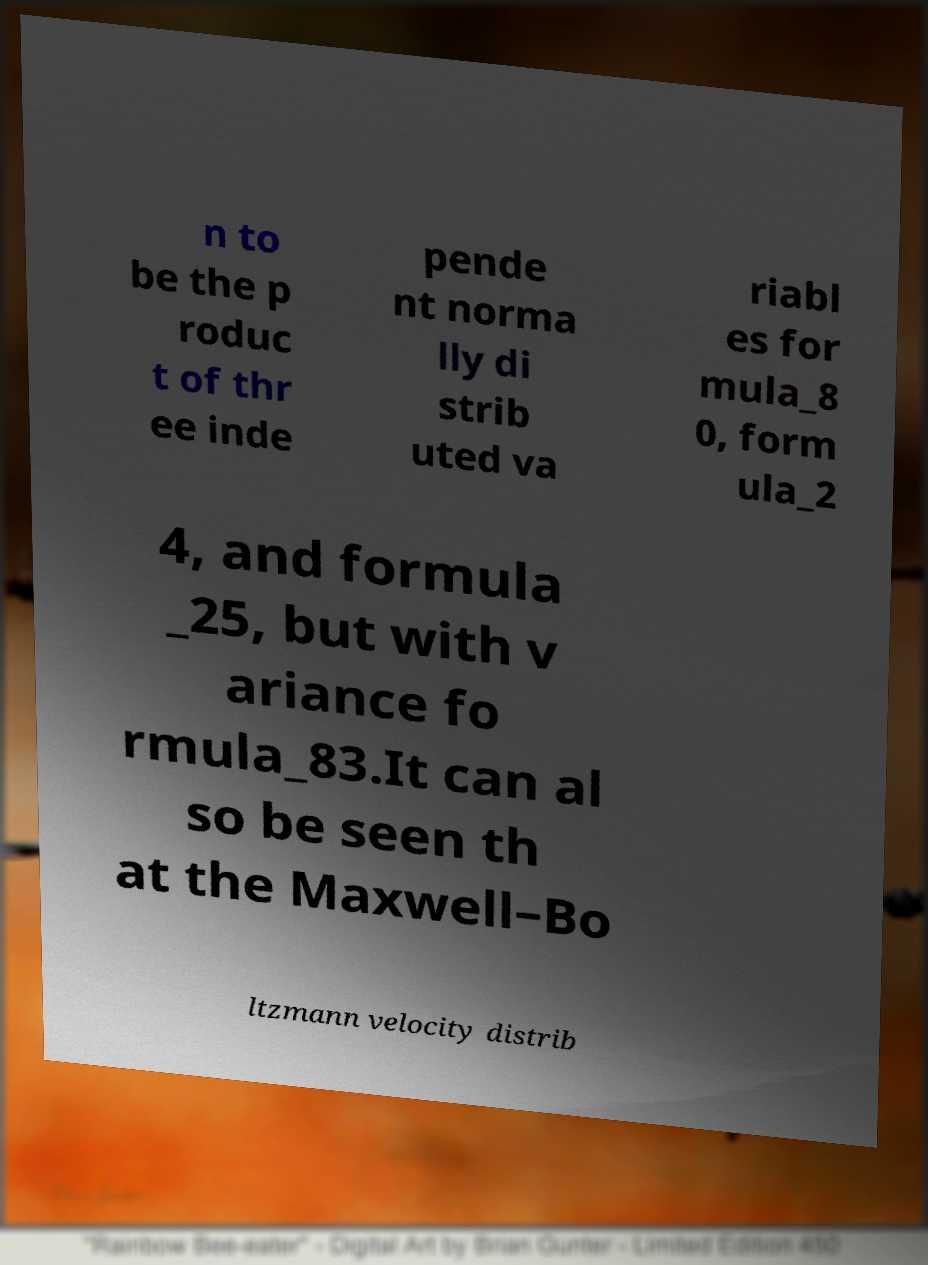Can you accurately transcribe the text from the provided image for me? n to be the p roduc t of thr ee inde pende nt norma lly di strib uted va riabl es for mula_8 0, form ula_2 4, and formula _25, but with v ariance fo rmula_83.It can al so be seen th at the Maxwell–Bo ltzmann velocity distrib 